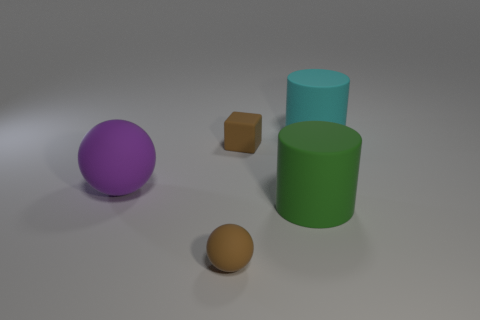Is the number of big matte things that are to the left of the green object greater than the number of large cylinders on the left side of the large cyan matte object?
Offer a very short reply. No. What number of spheres are in front of the large object that is on the left side of the tiny rubber sphere?
Give a very brief answer. 1. Is there a small thing of the same color as the rubber cube?
Give a very brief answer. Yes. Is the size of the cyan rubber object the same as the green cylinder?
Provide a succinct answer. Yes. Is the color of the rubber block the same as the small ball?
Your response must be concise. Yes. What material is the big object that is to the right of the big rubber thing in front of the purple sphere?
Give a very brief answer. Rubber. What is the material of the big cyan object that is the same shape as the large green rubber object?
Your response must be concise. Rubber. There is a matte cylinder in front of the cyan matte thing; is its size the same as the brown sphere?
Make the answer very short. No. What number of matte objects are either small brown blocks or big cyan objects?
Ensure brevity in your answer.  2. There is a object that is in front of the purple thing and left of the matte block; what size is it?
Offer a very short reply. Small. 